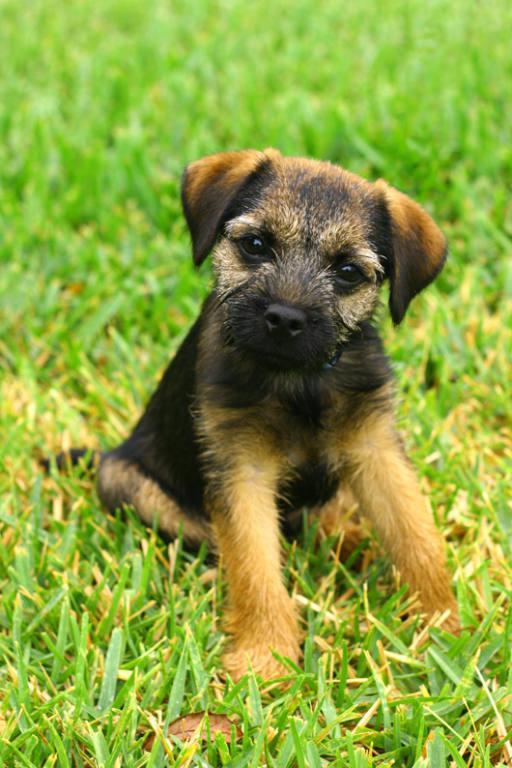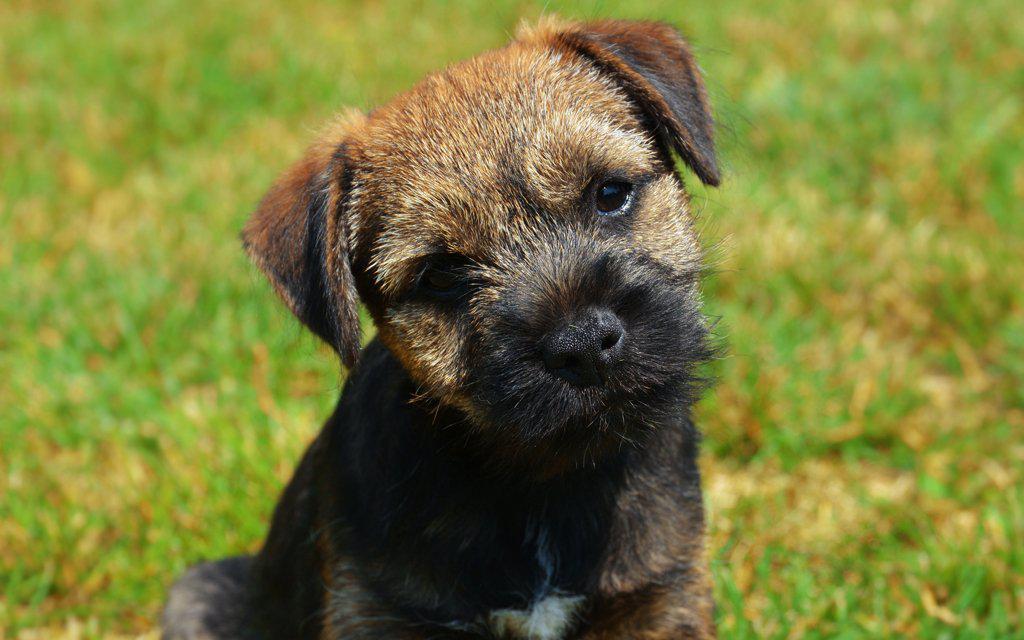The first image is the image on the left, the second image is the image on the right. Analyze the images presented: Is the assertion "The dog in the image on the left has only three feet on the ground." valid? Answer yes or no. No. 